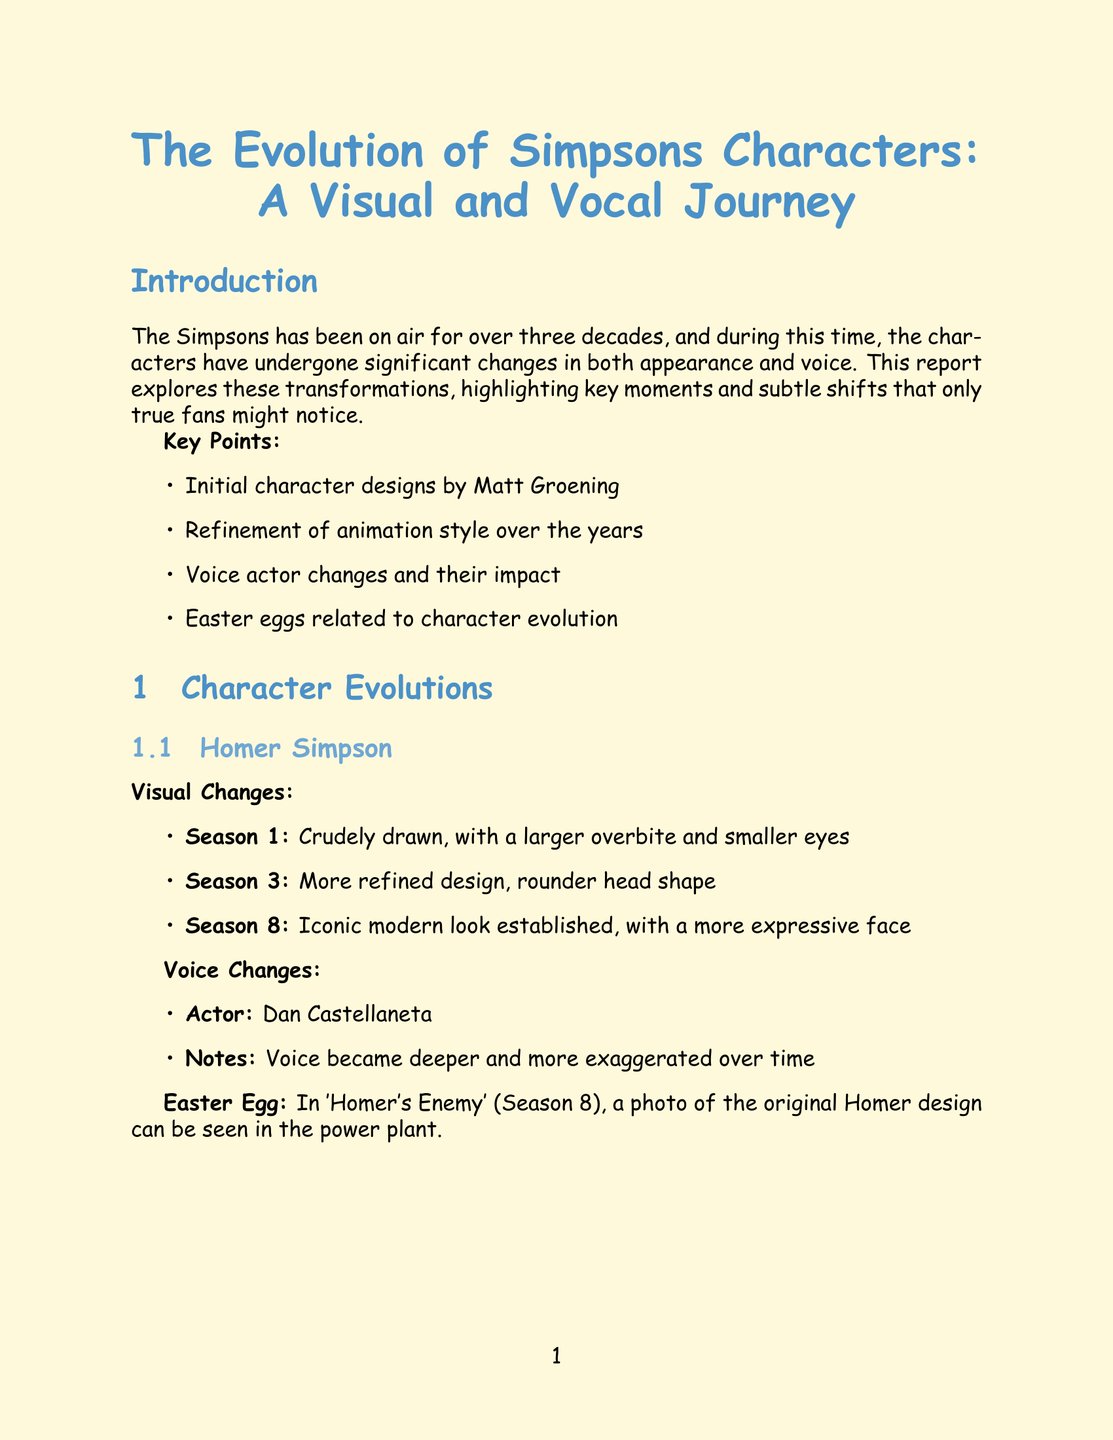What character had a larger overbite and smaller eyes in Season 1? The document specifies that Homer Simpson had a larger overbite and smaller eyes in Season 1.
Answer: Homer Simpson Who voiced Bart Simpson? The document identifies Nancy Cartwright as the voice actor for Bart Simpson.
Answer: Nancy Cartwright In which season did Marge's hair become more detailed and 'bouffant-like'? The report states that Marge's hair became more detailed and 'bouffant-like' in Season 4.
Answer: Season 4 What animation technique was used from 1995 to 2002? The document mentions that digital ink and paint was the animation technique used during this period.
Answer: Digital ink and paint What is an Easter egg related to Bart Simpson? The report notes that an original Bart sketch appears in 'The Day the Violence Died' (Season 7).
Answer: The Day the Violence Died How many decades has The Simpsons been on air? The introduction highlights that The Simpsons has been on air for over three decades.
Answer: Over three decades Which voice actor became raspier over the years? Julie Kavner is noted in the document as the voice actor whose voice became raspier over the years.
Answer: Julie Kavner What era used traditional cel animation? The document states that the era from 1989 to 1995 used traditional cel animation.
Answer: 1989-1995 